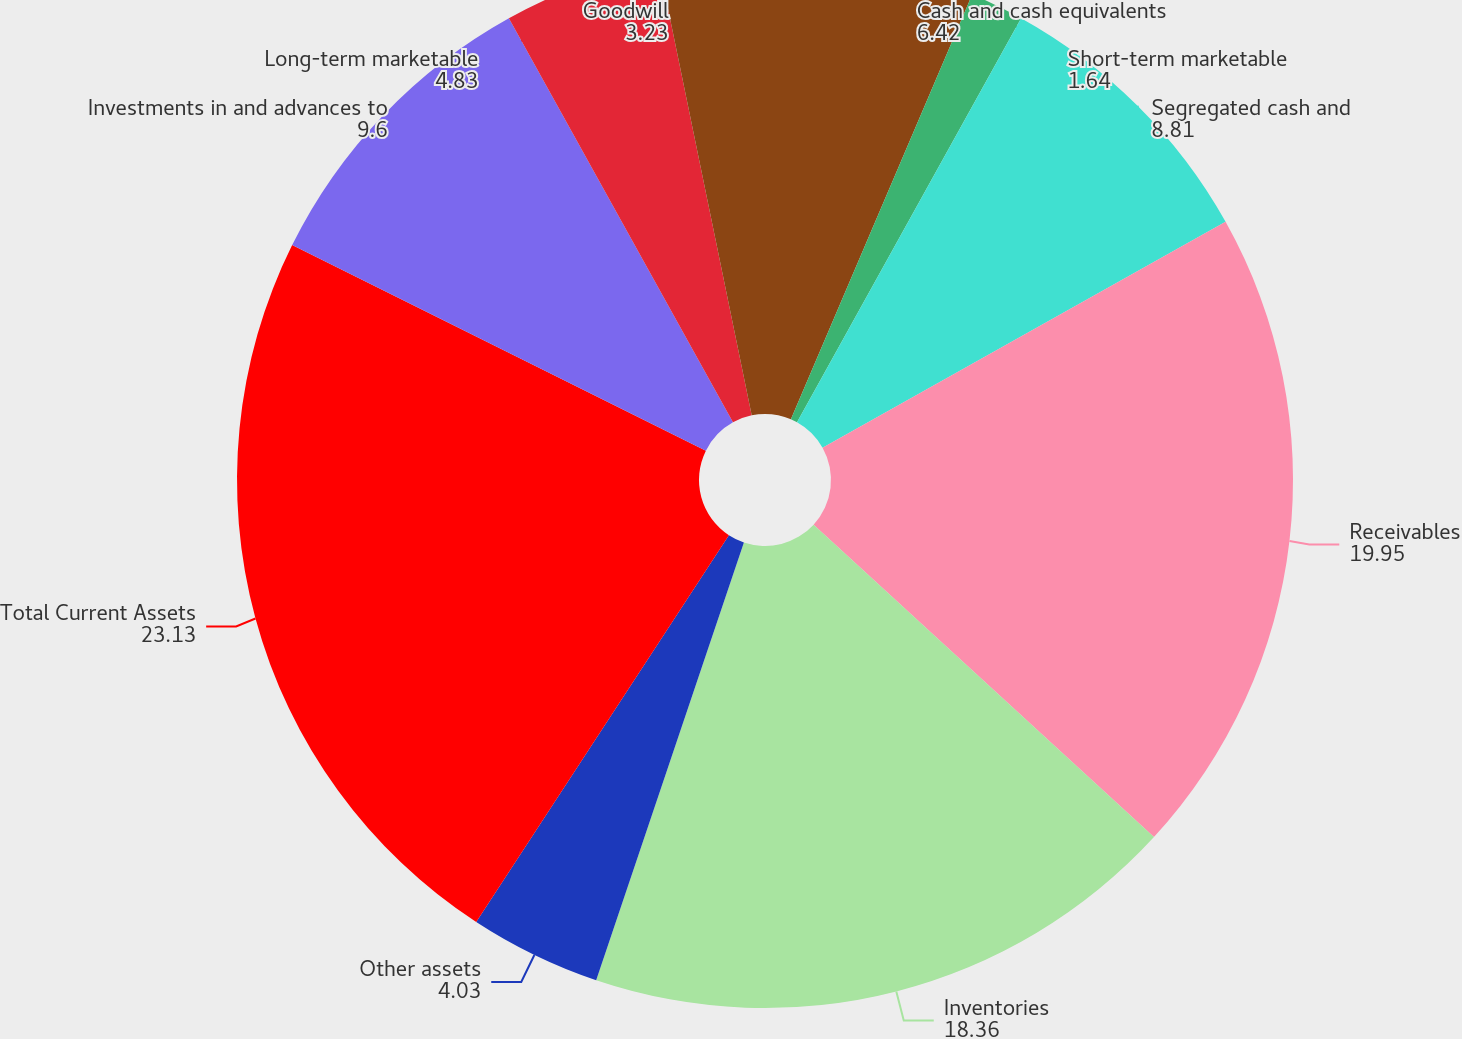Convert chart. <chart><loc_0><loc_0><loc_500><loc_500><pie_chart><fcel>Cash and cash equivalents<fcel>Short-term marketable<fcel>Segregated cash and<fcel>Receivables<fcel>Inventories<fcel>Other assets<fcel>Total Current Assets<fcel>Investments in and advances to<fcel>Long-term marketable<fcel>Goodwill<nl><fcel>6.42%<fcel>1.64%<fcel>8.81%<fcel>19.95%<fcel>18.36%<fcel>4.03%<fcel>23.13%<fcel>9.6%<fcel>4.83%<fcel>3.23%<nl></chart> 